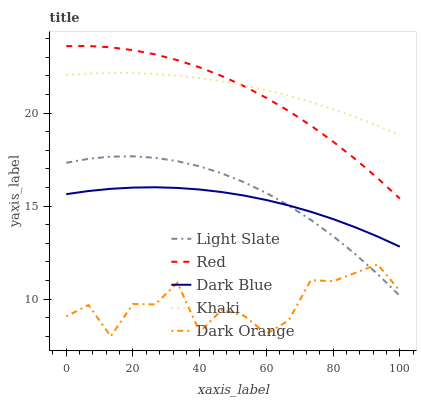Does Dark Orange have the minimum area under the curve?
Answer yes or no. Yes. Does Khaki have the maximum area under the curve?
Answer yes or no. Yes. Does Dark Blue have the minimum area under the curve?
Answer yes or no. No. Does Dark Blue have the maximum area under the curve?
Answer yes or no. No. Is Khaki the smoothest?
Answer yes or no. Yes. Is Dark Orange the roughest?
Answer yes or no. Yes. Is Dark Blue the smoothest?
Answer yes or no. No. Is Dark Blue the roughest?
Answer yes or no. No. Does Dark Orange have the lowest value?
Answer yes or no. Yes. Does Dark Blue have the lowest value?
Answer yes or no. No. Does Red have the highest value?
Answer yes or no. Yes. Does Dark Blue have the highest value?
Answer yes or no. No. Is Dark Orange less than Dark Blue?
Answer yes or no. Yes. Is Khaki greater than Light Slate?
Answer yes or no. Yes. Does Dark Orange intersect Light Slate?
Answer yes or no. Yes. Is Dark Orange less than Light Slate?
Answer yes or no. No. Is Dark Orange greater than Light Slate?
Answer yes or no. No. Does Dark Orange intersect Dark Blue?
Answer yes or no. No. 